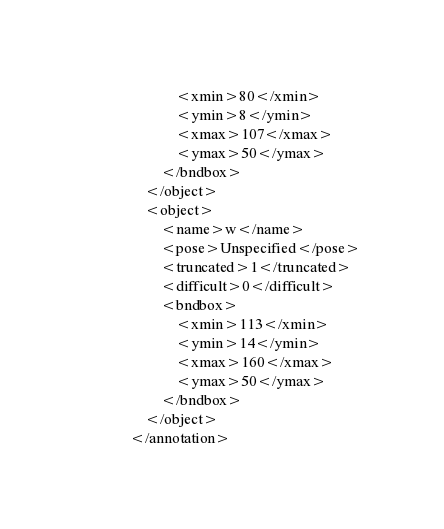<code> <loc_0><loc_0><loc_500><loc_500><_XML_>			<xmin>80</xmin>
			<ymin>8</ymin>
			<xmax>107</xmax>
			<ymax>50</ymax>
		</bndbox>
	</object>
	<object>
		<name>w</name>
		<pose>Unspecified</pose>
		<truncated>1</truncated>
		<difficult>0</difficult>
		<bndbox>
			<xmin>113</xmin>
			<ymin>14</ymin>
			<xmax>160</xmax>
			<ymax>50</ymax>
		</bndbox>
	</object>
</annotation>
</code> 